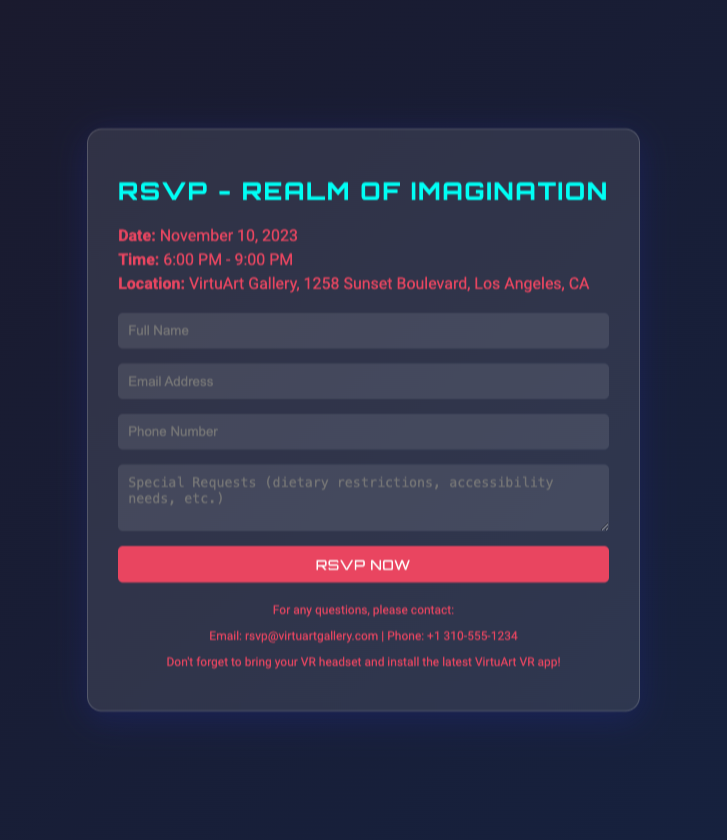what is the date of the event? The date is specified clearly in the event details section of the RSVP card.
Answer: November 10, 2023 what time does the event start? The start time is indicated in the event details section of the RSVP card.
Answer: 6:00 PM where is the event located? The location can be found in the event details section of the RSVP card.
Answer: VirtuArt Gallery, 1258 Sunset Boulevard, Los Angeles, CA what should attendees bring to the event? The additional information section discusses items that attendees should not forget to bring.
Answer: VR headset who should attendees contact for questions? The additional information section provides contact details for inquiries.
Answer: rsvp@virtuartgallery.com what is the RSVP submission method? The RSVP form indicates how attendees can respond to the invitation.
Answer: Online form are dietary restrictions mentioned in the RSVP? The RSVP form includes a specific section for attendees to detail any special requests.
Answer: Yes what is the dress code for the event? The document does not include dress code suggestions.
Answer: Not specified 